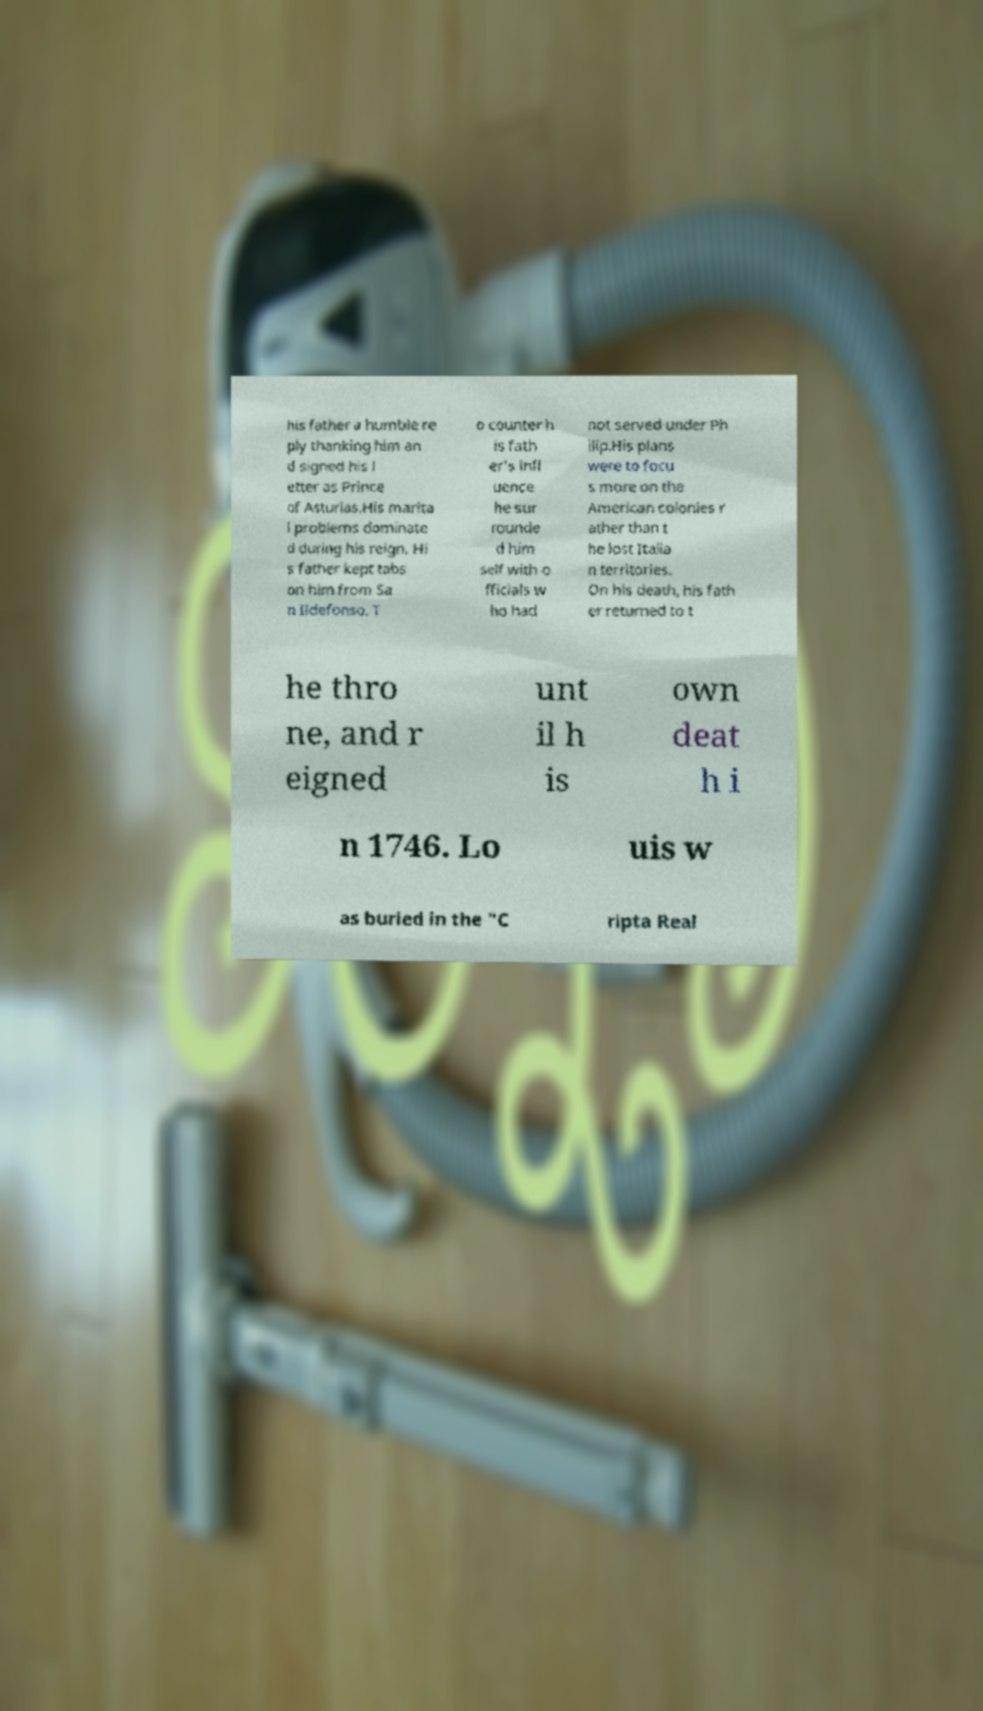What messages or text are displayed in this image? I need them in a readable, typed format. his father a humble re ply thanking him an d signed his l etter as Prince of Asturias.His marita l problems dominate d during his reign. Hi s father kept tabs on him from Sa n Ildefonso. T o counter h is fath er's infl uence he sur rounde d him self with o fficials w ho had not served under Ph ilip.His plans were to focu s more on the American colonies r ather than t he lost Italia n territories. On his death, his fath er returned to t he thro ne, and r eigned unt il h is own deat h i n 1746. Lo uis w as buried in the "C ripta Real 